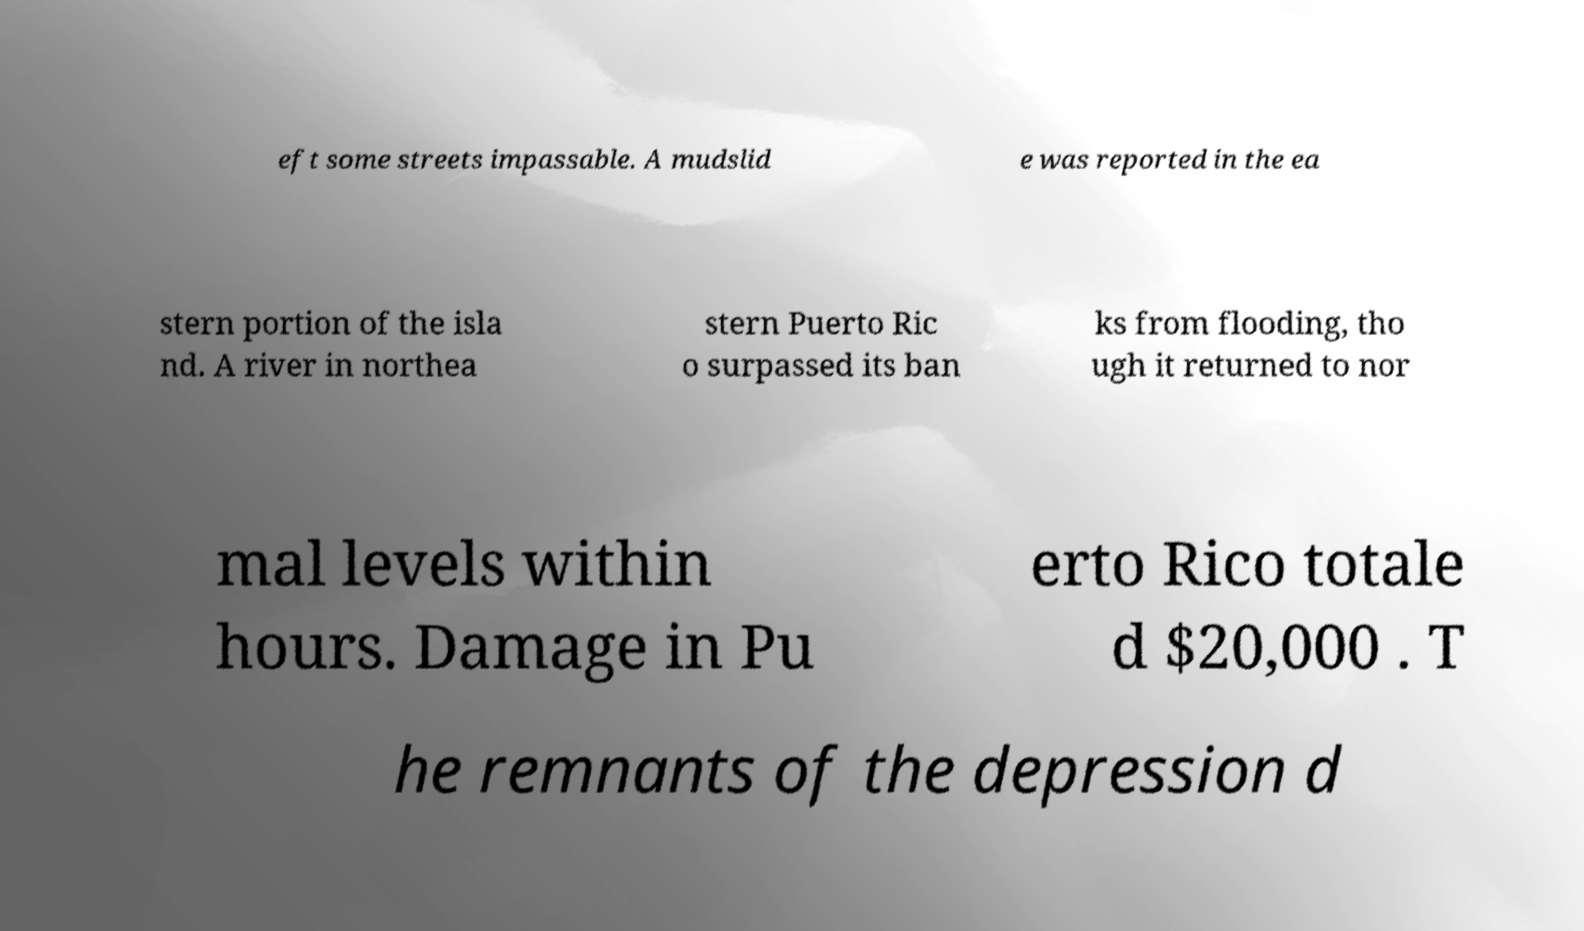Could you extract and type out the text from this image? eft some streets impassable. A mudslid e was reported in the ea stern portion of the isla nd. A river in northea stern Puerto Ric o surpassed its ban ks from flooding, tho ugh it returned to nor mal levels within hours. Damage in Pu erto Rico totale d $20,000 . T he remnants of the depression d 